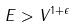Convert formula to latex. <formula><loc_0><loc_0><loc_500><loc_500>E > V ^ { 1 + \epsilon }</formula> 